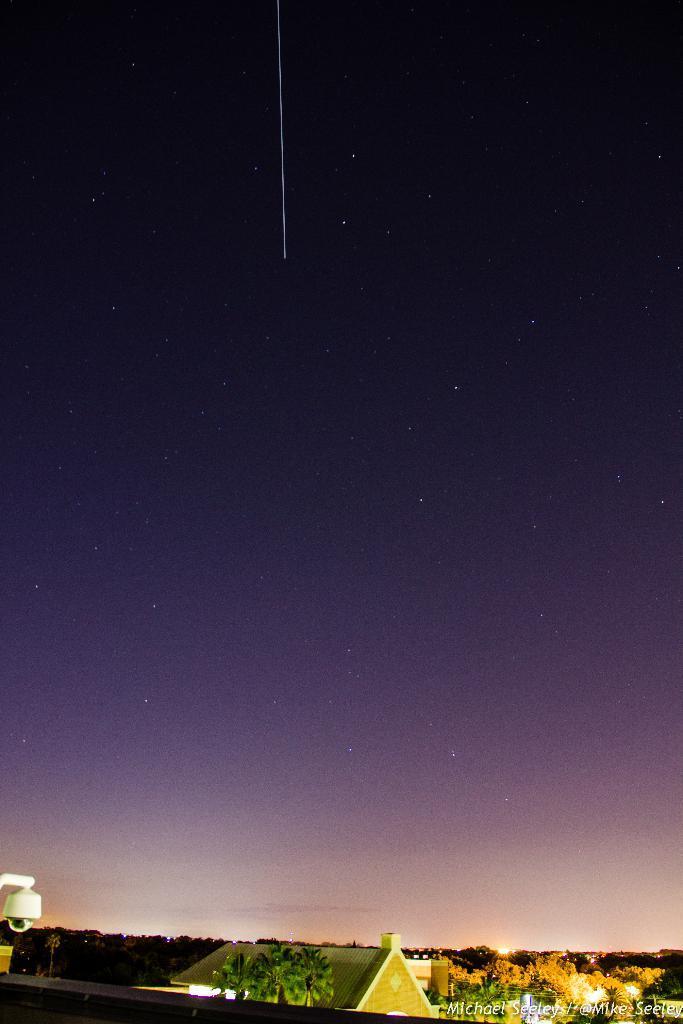Describe this image in one or two sentences. In this picture we can see a few houses and trees. There is a streetlight on the left side. We can see a watermark on the right side. 